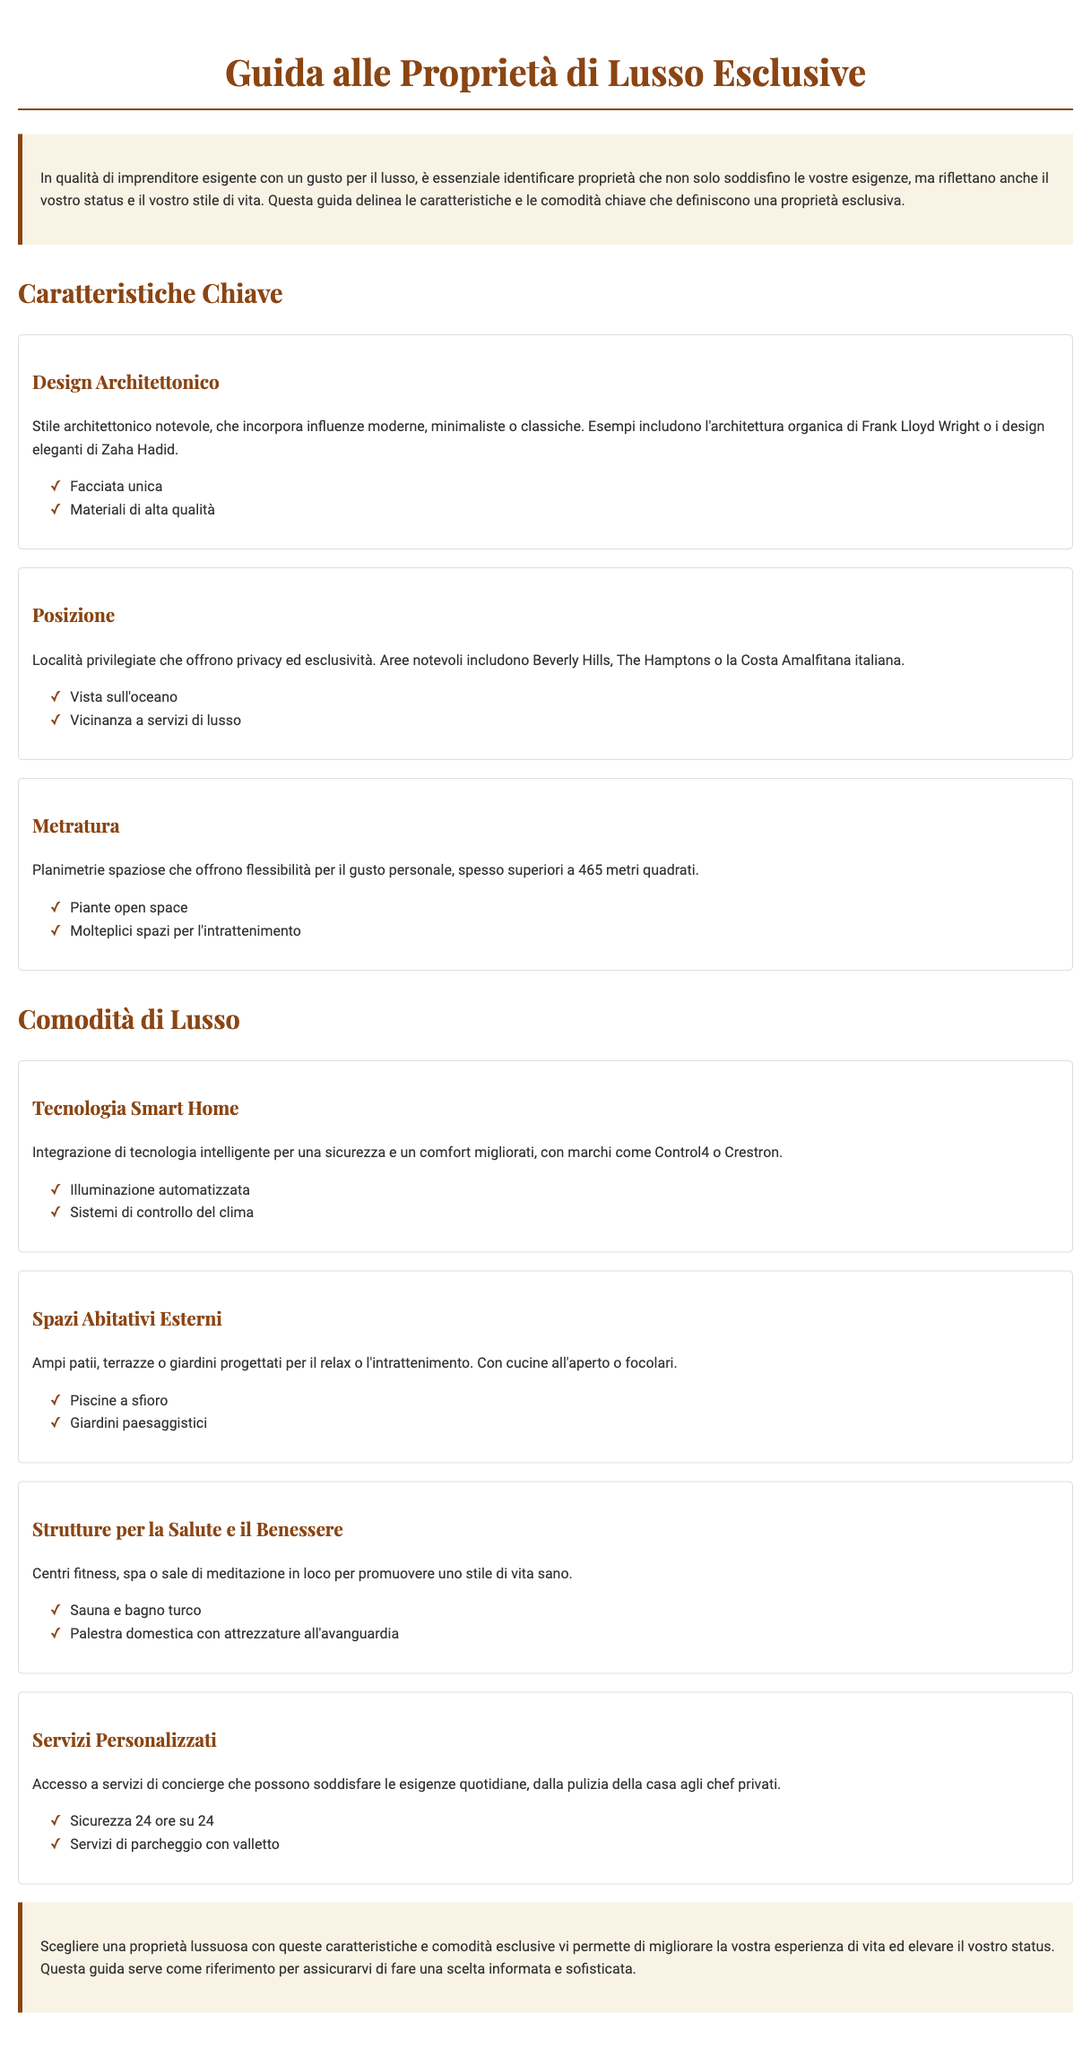Che cos'è il design architettonico nelle proprietà di lusso? Il design architettonico nelle proprietà di lusso è caratterizzato da uno stile notevole che incorpora influenze moderne, minimaliste o classiche.
Answer: Stile architettonico notevole Quali sono alcune delle posizioni privilegiate per le proprietà di lusso? Le posizioni privilegiate per le proprietà di lusso includono aree notevoli come Beverly Hills, The Hamptons o la Costa Amalfitana italiana.
Answer: Beverly Hills, The Hamptons, Costa Amalfitana Qual è la metratura tipica per le proprietà di lusso? La metratura tipica per le proprietà di lusso è spesso superiore a 465 metri quadrati.
Answer: Superiori a 465 metri quadrati Quali marchi sono associati alla tecnologia smart home? I marchi associati alla tecnologia smart home includono Control4 o Crestron.
Answer: Control4, Crestron Quali sono alcune comodità di lusso menzionate nel documento? Alcune comodità di lusso menzionate nel documento includono tecnologia smart home, spazi abitativi esterni, e strutture per la salute e il benessere.
Answer: Tecnologia smart home, spazi abitativi esterni, strutture per la salute e il benessere Qual è un esempio di un servizio personalizzato offerto in proprietà di lusso? Un esempio di servizio personalizzato è l'accesso a servizi di concierge per soddisfare le esigenze quotidiane.
Answer: Servizi di concierge Come migliorano queste caratteristiche l'esperienza di vita? Le caratteristiche e comodità esclusive migliorano l'esperienza di vita elevando lo status e offrendo comfort.
Answer: Elevano lo status e offrono comfort In quali modi una proprietà di lusso può riflettere il proprio stile di vita? Una proprietà di lusso può riflettere il proprio stile di vita attraverso design, posizione e servizi esclusivi.
Answer: Design, posizione e servizi esclusivi Quali elementi sono tipici degli spazi abitativi esterni? Gli spazi abitativi esterni tipici includono ampi patii, piscine a sfioro e giardini paesaggistici.
Answer: Ampi patii, piscine a sfioro, giardini paesaggistici 